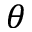<formula> <loc_0><loc_0><loc_500><loc_500>\theta</formula> 